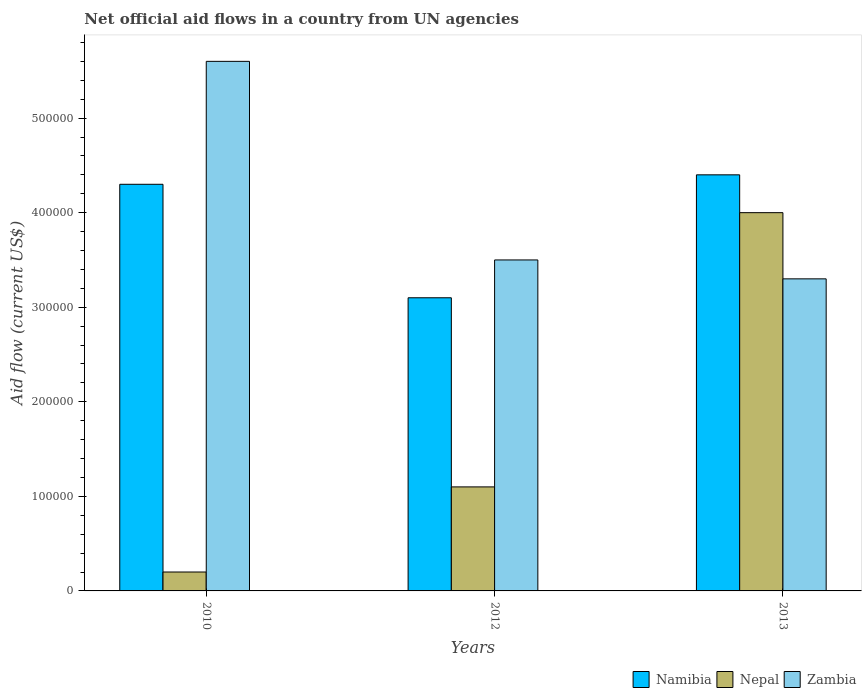How many groups of bars are there?
Make the answer very short. 3. What is the label of the 1st group of bars from the left?
Offer a terse response. 2010. What is the net official aid flow in Zambia in 2010?
Your answer should be very brief. 5.60e+05. Across all years, what is the maximum net official aid flow in Namibia?
Give a very brief answer. 4.40e+05. Across all years, what is the minimum net official aid flow in Nepal?
Your response must be concise. 2.00e+04. In which year was the net official aid flow in Namibia minimum?
Keep it short and to the point. 2012. What is the total net official aid flow in Namibia in the graph?
Provide a succinct answer. 1.18e+06. What is the difference between the net official aid flow in Namibia in 2012 and that in 2013?
Make the answer very short. -1.30e+05. What is the difference between the net official aid flow in Nepal in 2010 and the net official aid flow in Namibia in 2013?
Make the answer very short. -4.20e+05. What is the average net official aid flow in Nepal per year?
Provide a succinct answer. 1.77e+05. In the year 2013, what is the difference between the net official aid flow in Namibia and net official aid flow in Nepal?
Offer a very short reply. 4.00e+04. In how many years, is the net official aid flow in Nepal greater than 340000 US$?
Provide a short and direct response. 1. What is the ratio of the net official aid flow in Zambia in 2010 to that in 2013?
Your answer should be compact. 1.7. What is the difference between the highest and the second highest net official aid flow in Zambia?
Give a very brief answer. 2.10e+05. In how many years, is the net official aid flow in Namibia greater than the average net official aid flow in Namibia taken over all years?
Give a very brief answer. 2. Is the sum of the net official aid flow in Zambia in 2012 and 2013 greater than the maximum net official aid flow in Nepal across all years?
Keep it short and to the point. Yes. What does the 2nd bar from the left in 2012 represents?
Offer a very short reply. Nepal. What does the 2nd bar from the right in 2010 represents?
Your answer should be very brief. Nepal. Is it the case that in every year, the sum of the net official aid flow in Namibia and net official aid flow in Nepal is greater than the net official aid flow in Zambia?
Ensure brevity in your answer.  No. How many bars are there?
Offer a terse response. 9. How many years are there in the graph?
Provide a short and direct response. 3. Does the graph contain any zero values?
Your answer should be very brief. No. Does the graph contain grids?
Your answer should be very brief. No. Where does the legend appear in the graph?
Your answer should be compact. Bottom right. What is the title of the graph?
Give a very brief answer. Net official aid flows in a country from UN agencies. What is the label or title of the X-axis?
Provide a short and direct response. Years. What is the label or title of the Y-axis?
Offer a terse response. Aid flow (current US$). What is the Aid flow (current US$) of Nepal in 2010?
Make the answer very short. 2.00e+04. What is the Aid flow (current US$) of Zambia in 2010?
Keep it short and to the point. 5.60e+05. What is the Aid flow (current US$) in Namibia in 2012?
Offer a very short reply. 3.10e+05. What is the Aid flow (current US$) in Zambia in 2012?
Provide a short and direct response. 3.50e+05. Across all years, what is the maximum Aid flow (current US$) in Zambia?
Make the answer very short. 5.60e+05. Across all years, what is the minimum Aid flow (current US$) in Nepal?
Your response must be concise. 2.00e+04. What is the total Aid flow (current US$) of Namibia in the graph?
Offer a terse response. 1.18e+06. What is the total Aid flow (current US$) in Nepal in the graph?
Your response must be concise. 5.30e+05. What is the total Aid flow (current US$) in Zambia in the graph?
Keep it short and to the point. 1.24e+06. What is the difference between the Aid flow (current US$) in Namibia in 2010 and that in 2012?
Provide a short and direct response. 1.20e+05. What is the difference between the Aid flow (current US$) in Nepal in 2010 and that in 2012?
Your answer should be compact. -9.00e+04. What is the difference between the Aid flow (current US$) in Zambia in 2010 and that in 2012?
Your response must be concise. 2.10e+05. What is the difference between the Aid flow (current US$) in Nepal in 2010 and that in 2013?
Your answer should be very brief. -3.80e+05. What is the difference between the Aid flow (current US$) of Zambia in 2010 and that in 2013?
Ensure brevity in your answer.  2.30e+05. What is the difference between the Aid flow (current US$) in Namibia in 2012 and that in 2013?
Your answer should be compact. -1.30e+05. What is the difference between the Aid flow (current US$) of Nepal in 2012 and that in 2013?
Offer a terse response. -2.90e+05. What is the difference between the Aid flow (current US$) in Namibia in 2010 and the Aid flow (current US$) in Nepal in 2012?
Offer a terse response. 3.20e+05. What is the difference between the Aid flow (current US$) of Nepal in 2010 and the Aid flow (current US$) of Zambia in 2012?
Provide a succinct answer. -3.30e+05. What is the difference between the Aid flow (current US$) in Namibia in 2010 and the Aid flow (current US$) in Zambia in 2013?
Your answer should be very brief. 1.00e+05. What is the difference between the Aid flow (current US$) of Nepal in 2010 and the Aid flow (current US$) of Zambia in 2013?
Provide a succinct answer. -3.10e+05. What is the difference between the Aid flow (current US$) in Namibia in 2012 and the Aid flow (current US$) in Nepal in 2013?
Offer a terse response. -9.00e+04. What is the difference between the Aid flow (current US$) of Namibia in 2012 and the Aid flow (current US$) of Zambia in 2013?
Make the answer very short. -2.00e+04. What is the difference between the Aid flow (current US$) of Nepal in 2012 and the Aid flow (current US$) of Zambia in 2013?
Keep it short and to the point. -2.20e+05. What is the average Aid flow (current US$) of Namibia per year?
Provide a short and direct response. 3.93e+05. What is the average Aid flow (current US$) of Nepal per year?
Provide a succinct answer. 1.77e+05. What is the average Aid flow (current US$) in Zambia per year?
Your answer should be compact. 4.13e+05. In the year 2010, what is the difference between the Aid flow (current US$) of Namibia and Aid flow (current US$) of Zambia?
Give a very brief answer. -1.30e+05. In the year 2010, what is the difference between the Aid flow (current US$) of Nepal and Aid flow (current US$) of Zambia?
Offer a very short reply. -5.40e+05. In the year 2012, what is the difference between the Aid flow (current US$) in Namibia and Aid flow (current US$) in Nepal?
Give a very brief answer. 2.00e+05. In the year 2012, what is the difference between the Aid flow (current US$) in Namibia and Aid flow (current US$) in Zambia?
Keep it short and to the point. -4.00e+04. In the year 2013, what is the difference between the Aid flow (current US$) in Nepal and Aid flow (current US$) in Zambia?
Your response must be concise. 7.00e+04. What is the ratio of the Aid flow (current US$) of Namibia in 2010 to that in 2012?
Provide a succinct answer. 1.39. What is the ratio of the Aid flow (current US$) in Nepal in 2010 to that in 2012?
Your response must be concise. 0.18. What is the ratio of the Aid flow (current US$) in Namibia in 2010 to that in 2013?
Ensure brevity in your answer.  0.98. What is the ratio of the Aid flow (current US$) in Nepal in 2010 to that in 2013?
Ensure brevity in your answer.  0.05. What is the ratio of the Aid flow (current US$) in Zambia in 2010 to that in 2013?
Keep it short and to the point. 1.7. What is the ratio of the Aid flow (current US$) of Namibia in 2012 to that in 2013?
Your answer should be compact. 0.7. What is the ratio of the Aid flow (current US$) of Nepal in 2012 to that in 2013?
Provide a succinct answer. 0.28. What is the ratio of the Aid flow (current US$) in Zambia in 2012 to that in 2013?
Your response must be concise. 1.06. What is the difference between the highest and the second highest Aid flow (current US$) of Nepal?
Your answer should be very brief. 2.90e+05. What is the difference between the highest and the lowest Aid flow (current US$) of Nepal?
Provide a short and direct response. 3.80e+05. What is the difference between the highest and the lowest Aid flow (current US$) in Zambia?
Make the answer very short. 2.30e+05. 